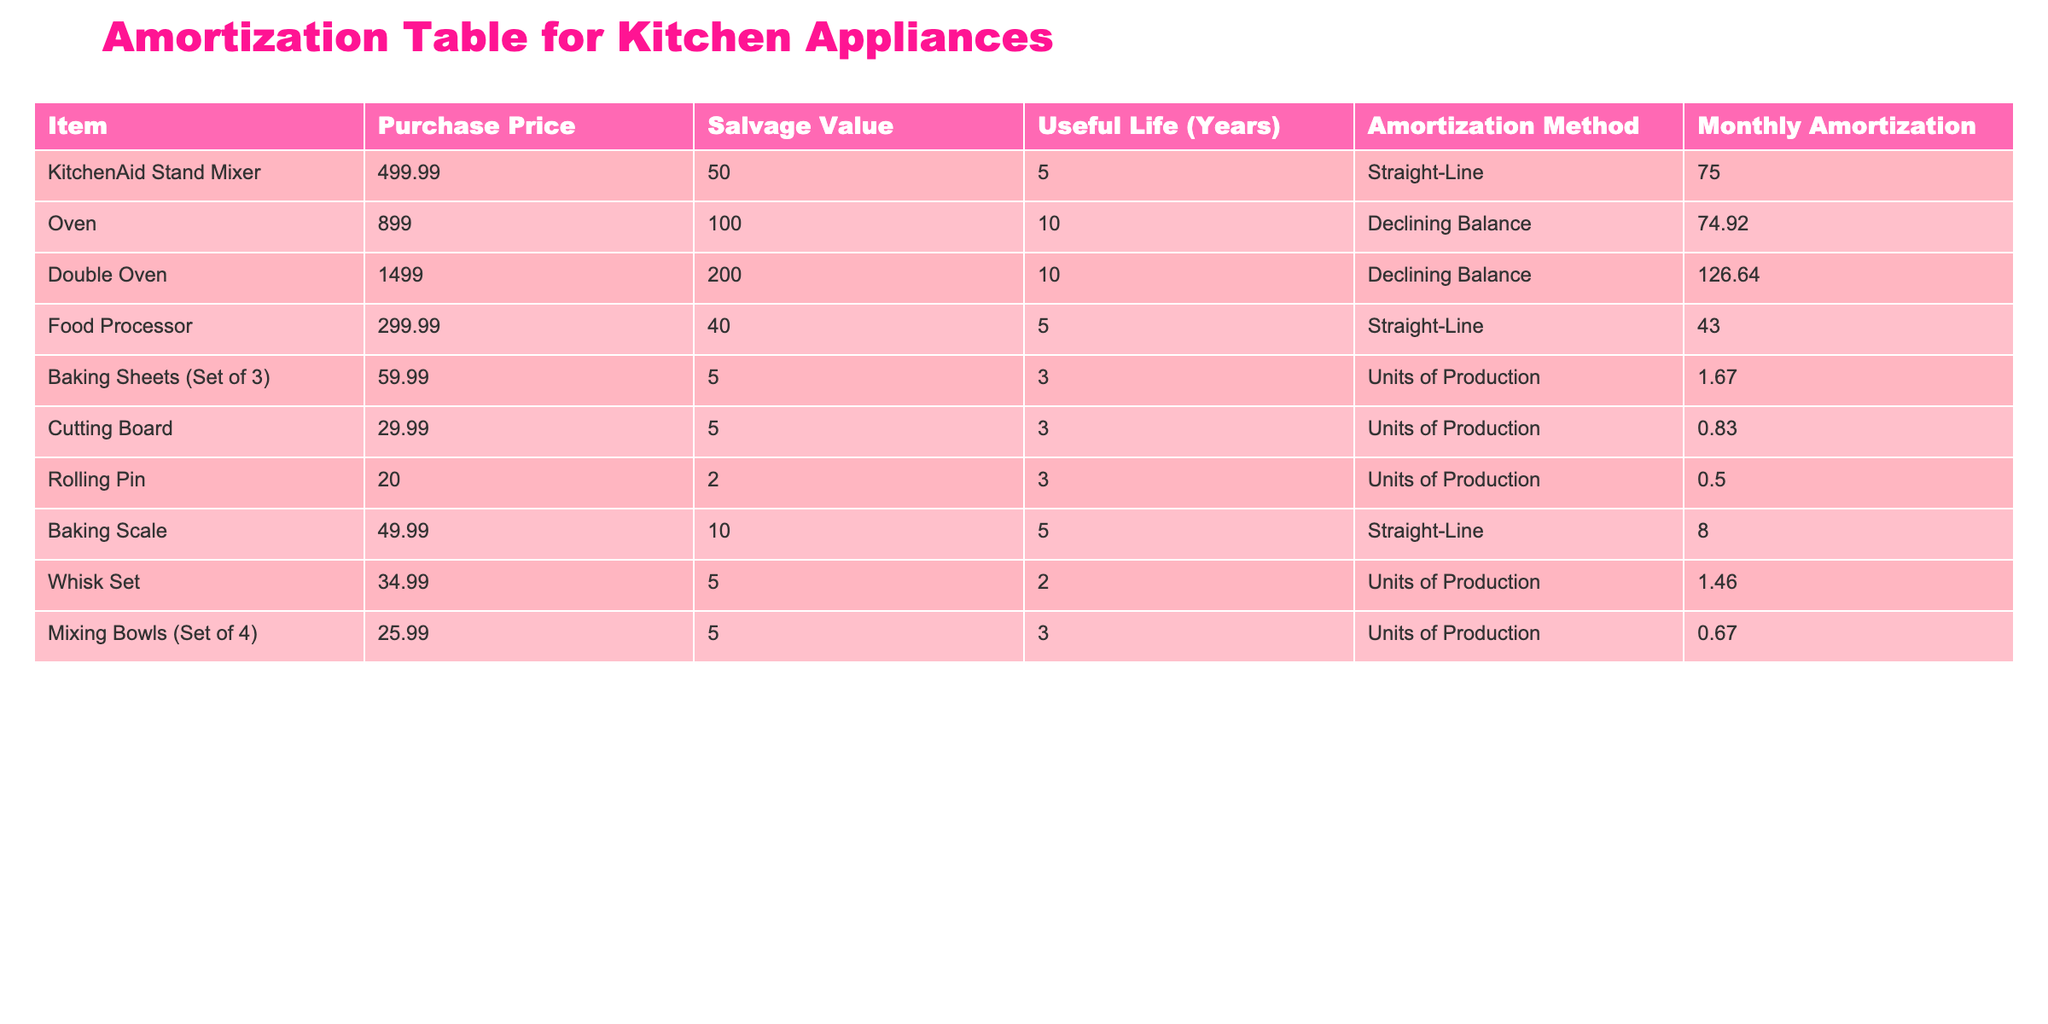What is the monthly amortization for the KitchenAid Stand Mixer? The table shows that the KitchenAid Stand Mixer has a listed monthly amortization of 75.00.
Answer: 75.00 What is the purchase price of the Double Oven? According to the table, the purchase price of the Double Oven is 1499.00.
Answer: 1499.00 Is the salvage value of the Food Processor higher than 40.00? The salvage value of the Food Processor is exactly 40.00, so the answer is no.
Answer: No What is the total monthly amortization for all the kitchen appliances combined? To find the total, we sum all the monthly amortization values: 75.00 + 74.92 + 126.64 + 43.00 + 1.67 + 0.83 + 0.50 + 8.00 + 1.46 + 0.67 = 332.29.
Answer: 332.29 Which appliance has the longest useful life according to the table? The Oven and Double Oven both have a useful life of 10 years, which is the longest among the listed items.
Answer: Oven and Double Oven What is the average monthly amortization for appliances with straight-line amortization? The straight-line amortization appliances are the KitchenAid Stand Mixer, Food Processor, and Baking Scale, with monthly amortization values of 75.00, 43.00, and 8.00. Summing these gives 126.00 and dividing by 3 gives an average of 42.00.
Answer: 42.00 Is the total salvage value of the baking sheets and cutting board greater than 10.00? The salvage values are 5.00 for the baking sheets and 5.00 for the cutting board, which totals 10.00. The total is not greater than 10.00.
Answer: No What is the difference in purchase price between the Double Oven and the Oven? The purchase price of the Double Oven is 1499.00 and the Oven is 899.00. Thus, the difference is 1499.00 - 899.00 = 600.00.
Answer: 600.00 What percentage of the salvage value does the KitchenAid Stand Mixer represent from its purchase price? The salvage value is 50.00 and the purchase price is 499.99. The percentage is calculated as (50.00 / 499.99) * 100, which equals approximately 10.00%.
Answer: 10.00% 